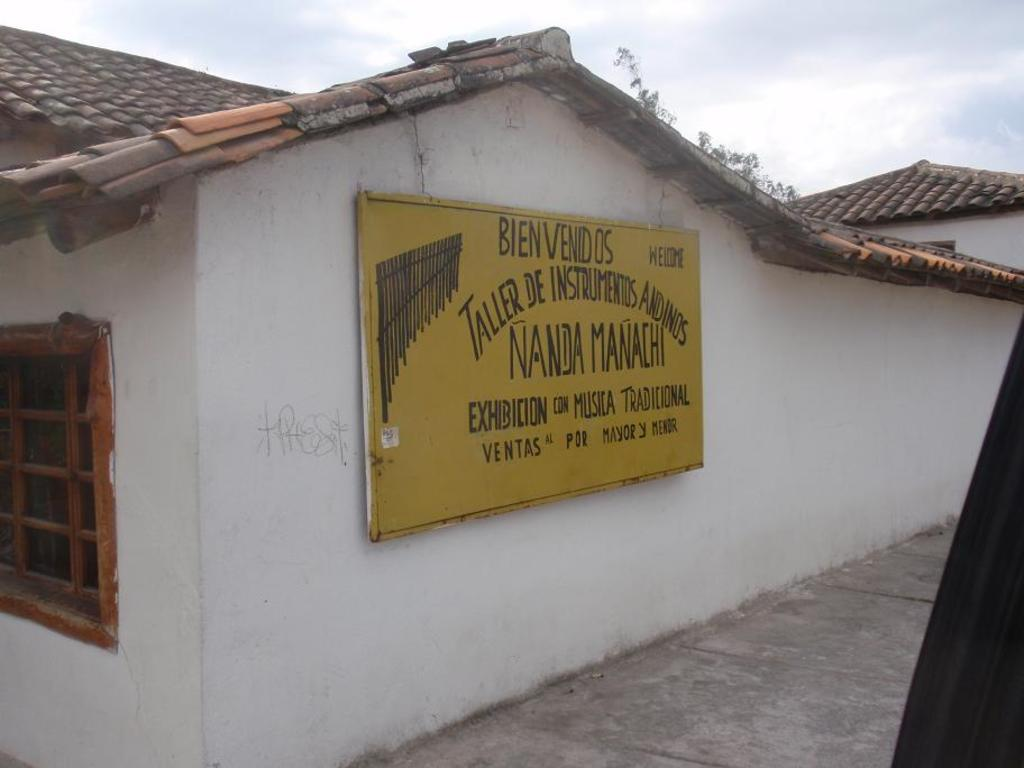<image>
Provide a brief description of the given image. the sign in foreign language saying Bien Venidos 